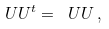Convert formula to latex. <formula><loc_0><loc_0><loc_500><loc_500>\ U U ^ { t } = \ U U \, ,</formula> 